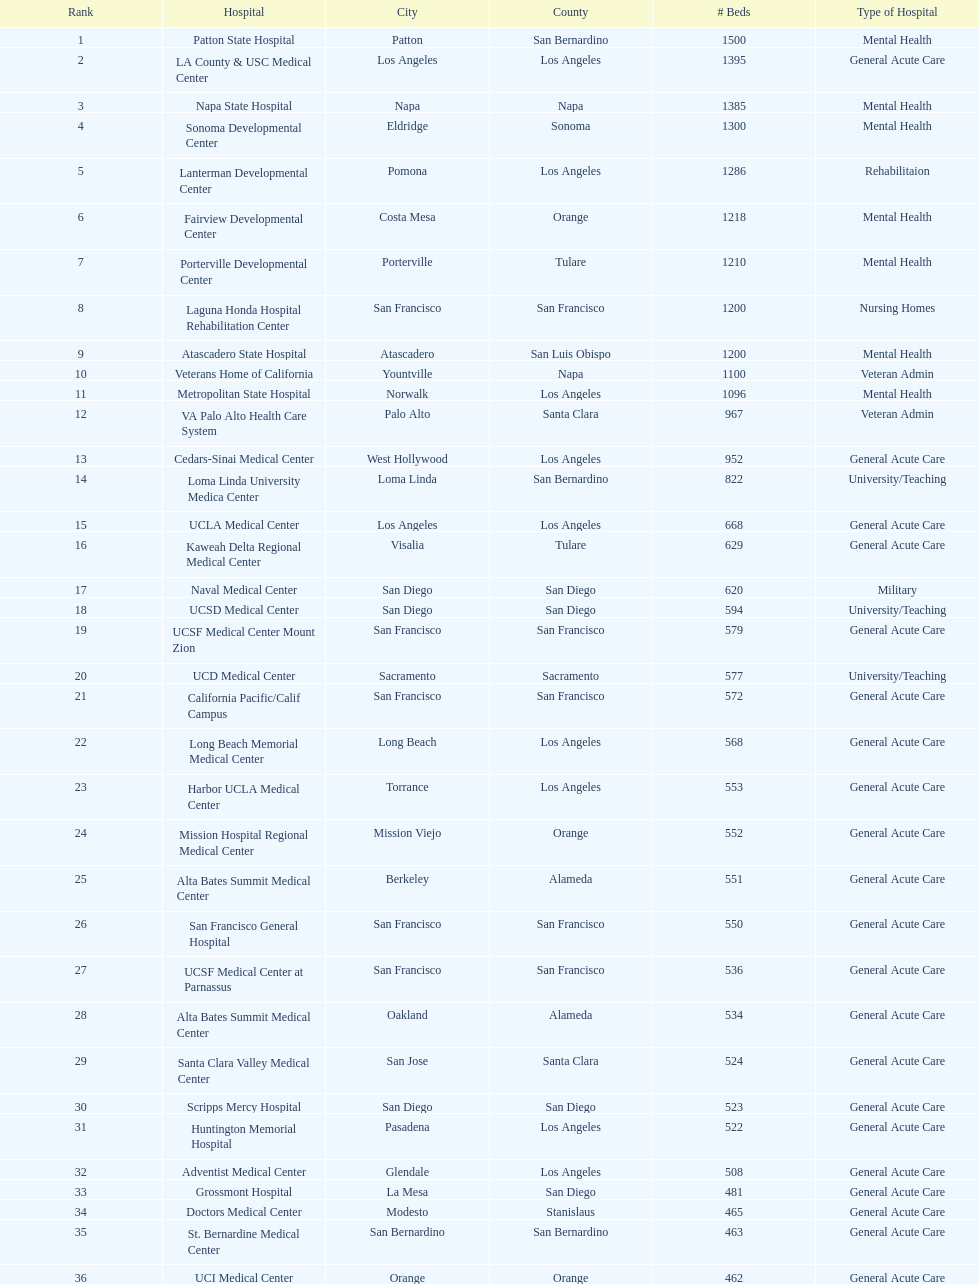What two hospitals holding consecutive rankings of 8 and 9 respectively, both provide 1200 hospital beds? Laguna Honda Hospital Rehabilitation Center, Atascadero State Hospital. 